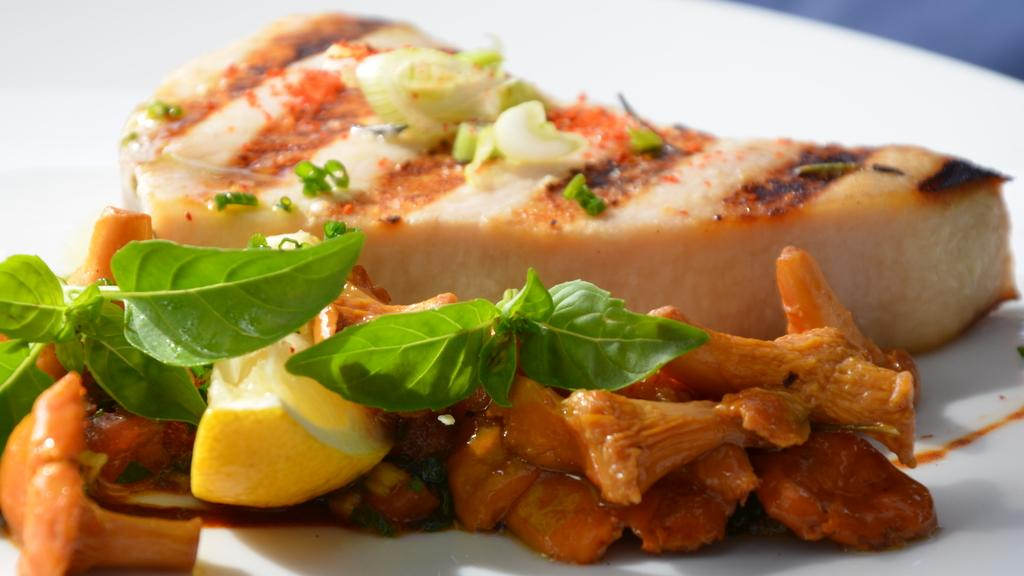What color is the plate that is visible in the image? The plate is white in color. What is on top of the plate in the image? There is a dish on the plate. What type of corn is being served on the plate in the image? There is no corn present on the plate in the image. 